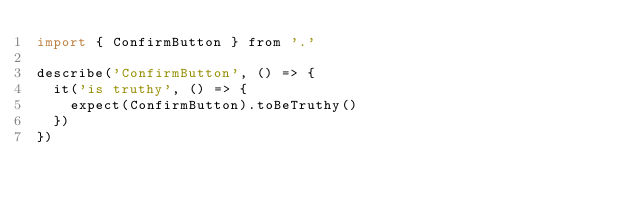<code> <loc_0><loc_0><loc_500><loc_500><_JavaScript_>import { ConfirmButton } from '.'

describe('ConfirmButton', () => {
  it('is truthy', () => {
    expect(ConfirmButton).toBeTruthy()
  })
})
</code> 